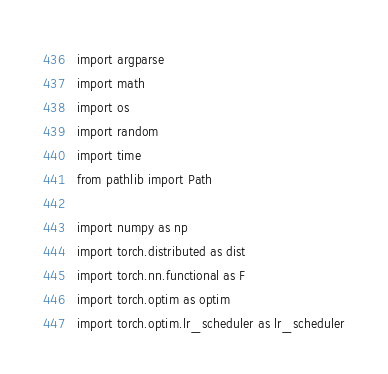<code> <loc_0><loc_0><loc_500><loc_500><_Python_>import argparse
import math
import os
import random
import time
from pathlib import Path

import numpy as np
import torch.distributed as dist
import torch.nn.functional as F
import torch.optim as optim
import torch.optim.lr_scheduler as lr_scheduler</code> 